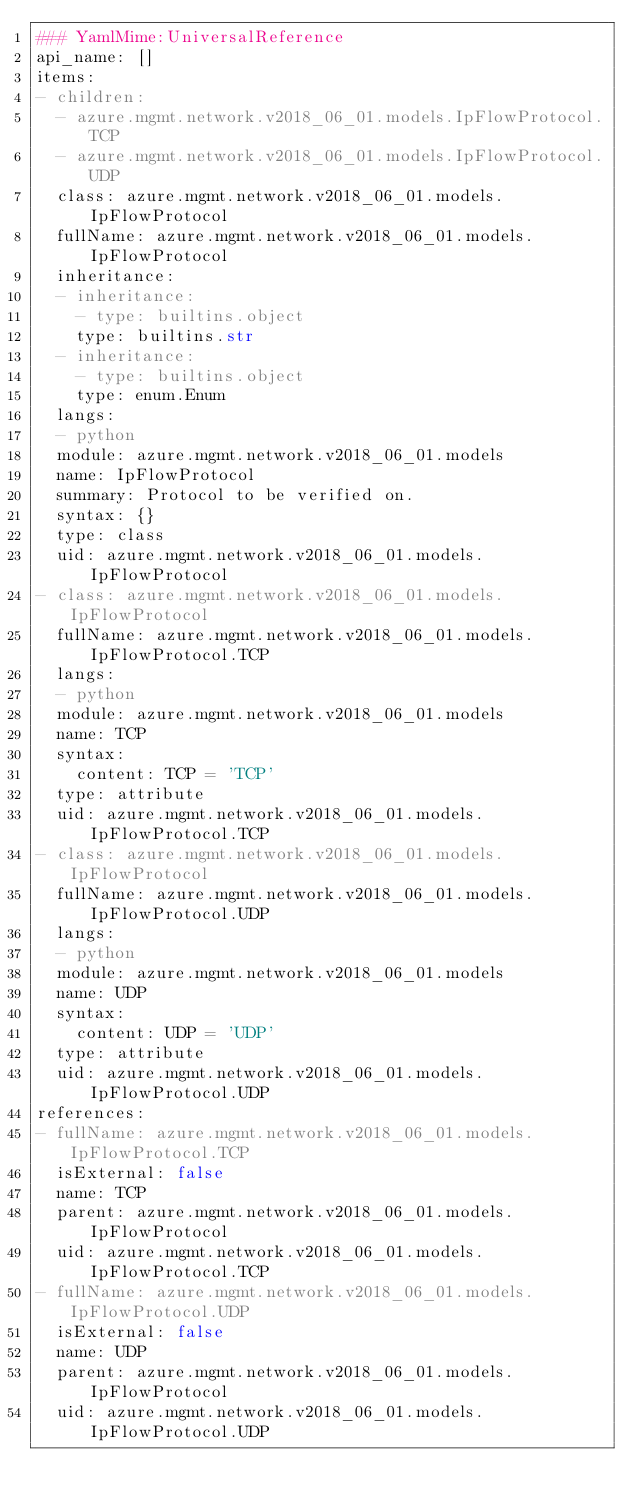Convert code to text. <code><loc_0><loc_0><loc_500><loc_500><_YAML_>### YamlMime:UniversalReference
api_name: []
items:
- children:
  - azure.mgmt.network.v2018_06_01.models.IpFlowProtocol.TCP
  - azure.mgmt.network.v2018_06_01.models.IpFlowProtocol.UDP
  class: azure.mgmt.network.v2018_06_01.models.IpFlowProtocol
  fullName: azure.mgmt.network.v2018_06_01.models.IpFlowProtocol
  inheritance:
  - inheritance:
    - type: builtins.object
    type: builtins.str
  - inheritance:
    - type: builtins.object
    type: enum.Enum
  langs:
  - python
  module: azure.mgmt.network.v2018_06_01.models
  name: IpFlowProtocol
  summary: Protocol to be verified on.
  syntax: {}
  type: class
  uid: azure.mgmt.network.v2018_06_01.models.IpFlowProtocol
- class: azure.mgmt.network.v2018_06_01.models.IpFlowProtocol
  fullName: azure.mgmt.network.v2018_06_01.models.IpFlowProtocol.TCP
  langs:
  - python
  module: azure.mgmt.network.v2018_06_01.models
  name: TCP
  syntax:
    content: TCP = 'TCP'
  type: attribute
  uid: azure.mgmt.network.v2018_06_01.models.IpFlowProtocol.TCP
- class: azure.mgmt.network.v2018_06_01.models.IpFlowProtocol
  fullName: azure.mgmt.network.v2018_06_01.models.IpFlowProtocol.UDP
  langs:
  - python
  module: azure.mgmt.network.v2018_06_01.models
  name: UDP
  syntax:
    content: UDP = 'UDP'
  type: attribute
  uid: azure.mgmt.network.v2018_06_01.models.IpFlowProtocol.UDP
references:
- fullName: azure.mgmt.network.v2018_06_01.models.IpFlowProtocol.TCP
  isExternal: false
  name: TCP
  parent: azure.mgmt.network.v2018_06_01.models.IpFlowProtocol
  uid: azure.mgmt.network.v2018_06_01.models.IpFlowProtocol.TCP
- fullName: azure.mgmt.network.v2018_06_01.models.IpFlowProtocol.UDP
  isExternal: false
  name: UDP
  parent: azure.mgmt.network.v2018_06_01.models.IpFlowProtocol
  uid: azure.mgmt.network.v2018_06_01.models.IpFlowProtocol.UDP
</code> 